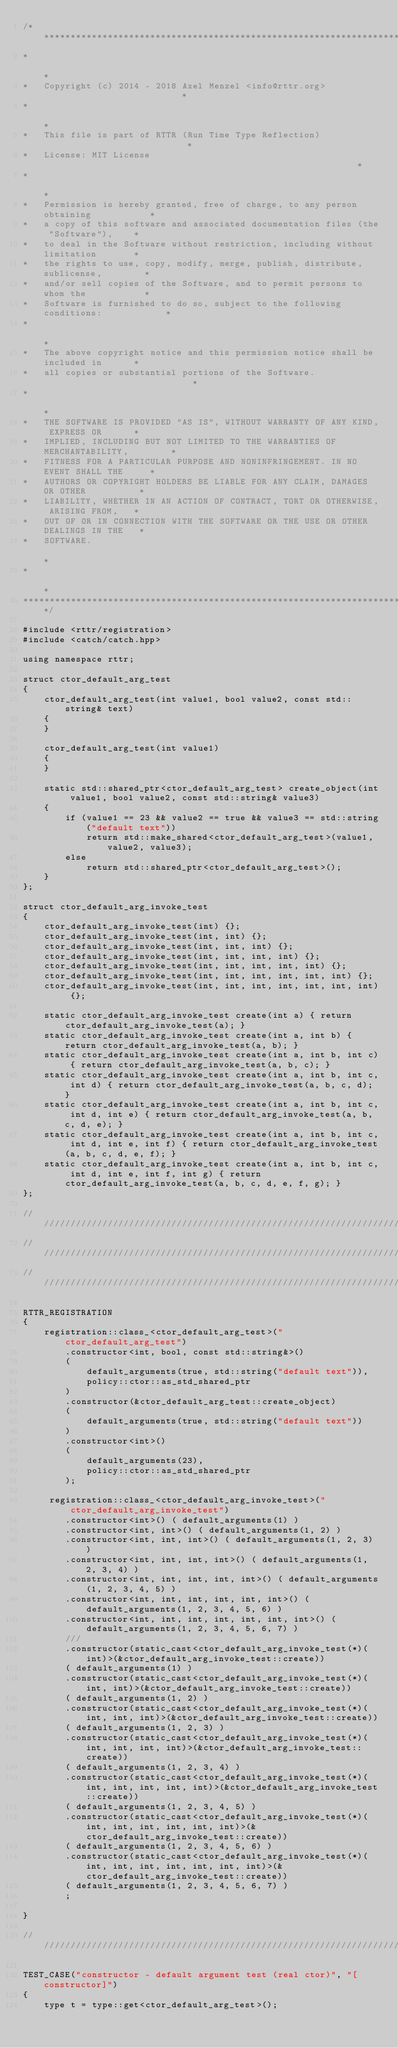<code> <loc_0><loc_0><loc_500><loc_500><_C++_>/************************************************************************************
*                                                                                   *
*   Copyright (c) 2014 - 2018 Axel Menzel <info@rttr.org>                           *
*                                                                                   *
*   This file is part of RTTR (Run Time Type Reflection)                            *
*   License: MIT License                                                            *
*                                                                                   *
*   Permission is hereby granted, free of charge, to any person obtaining           *
*   a copy of this software and associated documentation files (the "Software"),    *
*   to deal in the Software without restriction, including without limitation       *
*   the rights to use, copy, modify, merge, publish, distribute, sublicense,        *
*   and/or sell copies of the Software, and to permit persons to whom the           *
*   Software is furnished to do so, subject to the following conditions:            *
*                                                                                   *
*   The above copyright notice and this permission notice shall be included in      *
*   all copies or substantial portions of the Software.                             *
*                                                                                   *
*   THE SOFTWARE IS PROVIDED "AS IS", WITHOUT WARRANTY OF ANY KIND, EXPRESS OR      *
*   IMPLIED, INCLUDING BUT NOT LIMITED TO THE WARRANTIES OF MERCHANTABILITY,        *
*   FITNESS FOR A PARTICULAR PURPOSE AND NONINFRINGEMENT. IN NO EVENT SHALL THE     *
*   AUTHORS OR COPYRIGHT HOLDERS BE LIABLE FOR ANY CLAIM, DAMAGES OR OTHER          *
*   LIABILITY, WHETHER IN AN ACTION OF CONTRACT, TORT OR OTHERWISE, ARISING FROM,   *
*   OUT OF OR IN CONNECTION WITH THE SOFTWARE OR THE USE OR OTHER DEALINGS IN THE   *
*   SOFTWARE.                                                                       *
*                                                                                   *
*************************************************************************************/

#include <rttr/registration>
#include <catch/catch.hpp>

using namespace rttr;

struct ctor_default_arg_test
{
    ctor_default_arg_test(int value1, bool value2, const std::string& text)
    {
    }

    ctor_default_arg_test(int value1)
    {
    }

    static std::shared_ptr<ctor_default_arg_test> create_object(int value1, bool value2, const std::string& value3)
    {
        if (value1 == 23 && value2 == true && value3 == std::string("default text"))
            return std::make_shared<ctor_default_arg_test>(value1, value2, value3);
        else
            return std::shared_ptr<ctor_default_arg_test>();
    }
};

struct ctor_default_arg_invoke_test
{
    ctor_default_arg_invoke_test(int) {};
    ctor_default_arg_invoke_test(int, int) {};
    ctor_default_arg_invoke_test(int, int, int) {};
    ctor_default_arg_invoke_test(int, int, int, int) {};
    ctor_default_arg_invoke_test(int, int, int, int, int) {};
    ctor_default_arg_invoke_test(int, int, int, int, int, int) {};
    ctor_default_arg_invoke_test(int, int, int, int, int, int, int) {};

    static ctor_default_arg_invoke_test create(int a) { return ctor_default_arg_invoke_test(a); }
    static ctor_default_arg_invoke_test create(int a, int b) { return ctor_default_arg_invoke_test(a, b); }
    static ctor_default_arg_invoke_test create(int a, int b, int c) { return ctor_default_arg_invoke_test(a, b, c); }
    static ctor_default_arg_invoke_test create(int a, int b, int c, int d) { return ctor_default_arg_invoke_test(a, b, c, d); }
    static ctor_default_arg_invoke_test create(int a, int b, int c, int d, int e) { return ctor_default_arg_invoke_test(a, b, c, d, e); }
    static ctor_default_arg_invoke_test create(int a, int b, int c, int d, int e, int f) { return ctor_default_arg_invoke_test(a, b, c, d, e, f); }
    static ctor_default_arg_invoke_test create(int a, int b, int c, int d, int e, int f, int g) { return ctor_default_arg_invoke_test(a, b, c, d, e, f, g); }
};

/////////////////////////////////////////////////////////////////////////////////////////
/////////////////////////////////////////////////////////////////////////////////////////
/////////////////////////////////////////////////////////////////////////////////////////

RTTR_REGISTRATION
{
    registration::class_<ctor_default_arg_test>("ctor_default_arg_test")
        .constructor<int, bool, const std::string&>()
        (
            default_arguments(true, std::string("default text")),
            policy::ctor::as_std_shared_ptr
        )
        .constructor(&ctor_default_arg_test::create_object)
        (
            default_arguments(true, std::string("default text"))
        )
        .constructor<int>()
        (
            default_arguments(23),
            policy::ctor::as_std_shared_ptr
        );

     registration::class_<ctor_default_arg_invoke_test>("ctor_default_arg_invoke_test")
        .constructor<int>() ( default_arguments(1) )
        .constructor<int, int>() ( default_arguments(1, 2) )
        .constructor<int, int, int>() ( default_arguments(1, 2, 3) )
        .constructor<int, int, int, int>() ( default_arguments(1, 2, 3, 4) )
        .constructor<int, int, int, int, int>() ( default_arguments(1, 2, 3, 4, 5) )
        .constructor<int, int, int, int, int, int>() ( default_arguments(1, 2, 3, 4, 5, 6) )
        .constructor<int, int, int, int, int, int, int>() ( default_arguments(1, 2, 3, 4, 5, 6, 7) )
        ///
        .constructor(static_cast<ctor_default_arg_invoke_test(*)(int)>(&ctor_default_arg_invoke_test::create))
        ( default_arguments(1) )
        .constructor(static_cast<ctor_default_arg_invoke_test(*)(int, int)>(&ctor_default_arg_invoke_test::create))
        ( default_arguments(1, 2) )
        .constructor(static_cast<ctor_default_arg_invoke_test(*)(int, int, int)>(&ctor_default_arg_invoke_test::create))
        ( default_arguments(1, 2, 3) )
        .constructor(static_cast<ctor_default_arg_invoke_test(*)(int, int, int, int)>(&ctor_default_arg_invoke_test::create))
        ( default_arguments(1, 2, 3, 4) )
        .constructor(static_cast<ctor_default_arg_invoke_test(*)(int, int, int, int, int)>(&ctor_default_arg_invoke_test::create))
        ( default_arguments(1, 2, 3, 4, 5) )
        .constructor(static_cast<ctor_default_arg_invoke_test(*)(int, int, int, int, int, int)>(&ctor_default_arg_invoke_test::create))
        ( default_arguments(1, 2, 3, 4, 5, 6) )
        .constructor(static_cast<ctor_default_arg_invoke_test(*)(int, int, int, int, int, int, int)>(&ctor_default_arg_invoke_test::create))
        ( default_arguments(1, 2, 3, 4, 5, 6, 7) )
        ;

}

////////////////////////////////////////////////////////////////////////////////////////

TEST_CASE("constructor - default argument test (real ctor)", "[constructor]")
{
    type t = type::get<ctor_default_arg_test>();</code> 